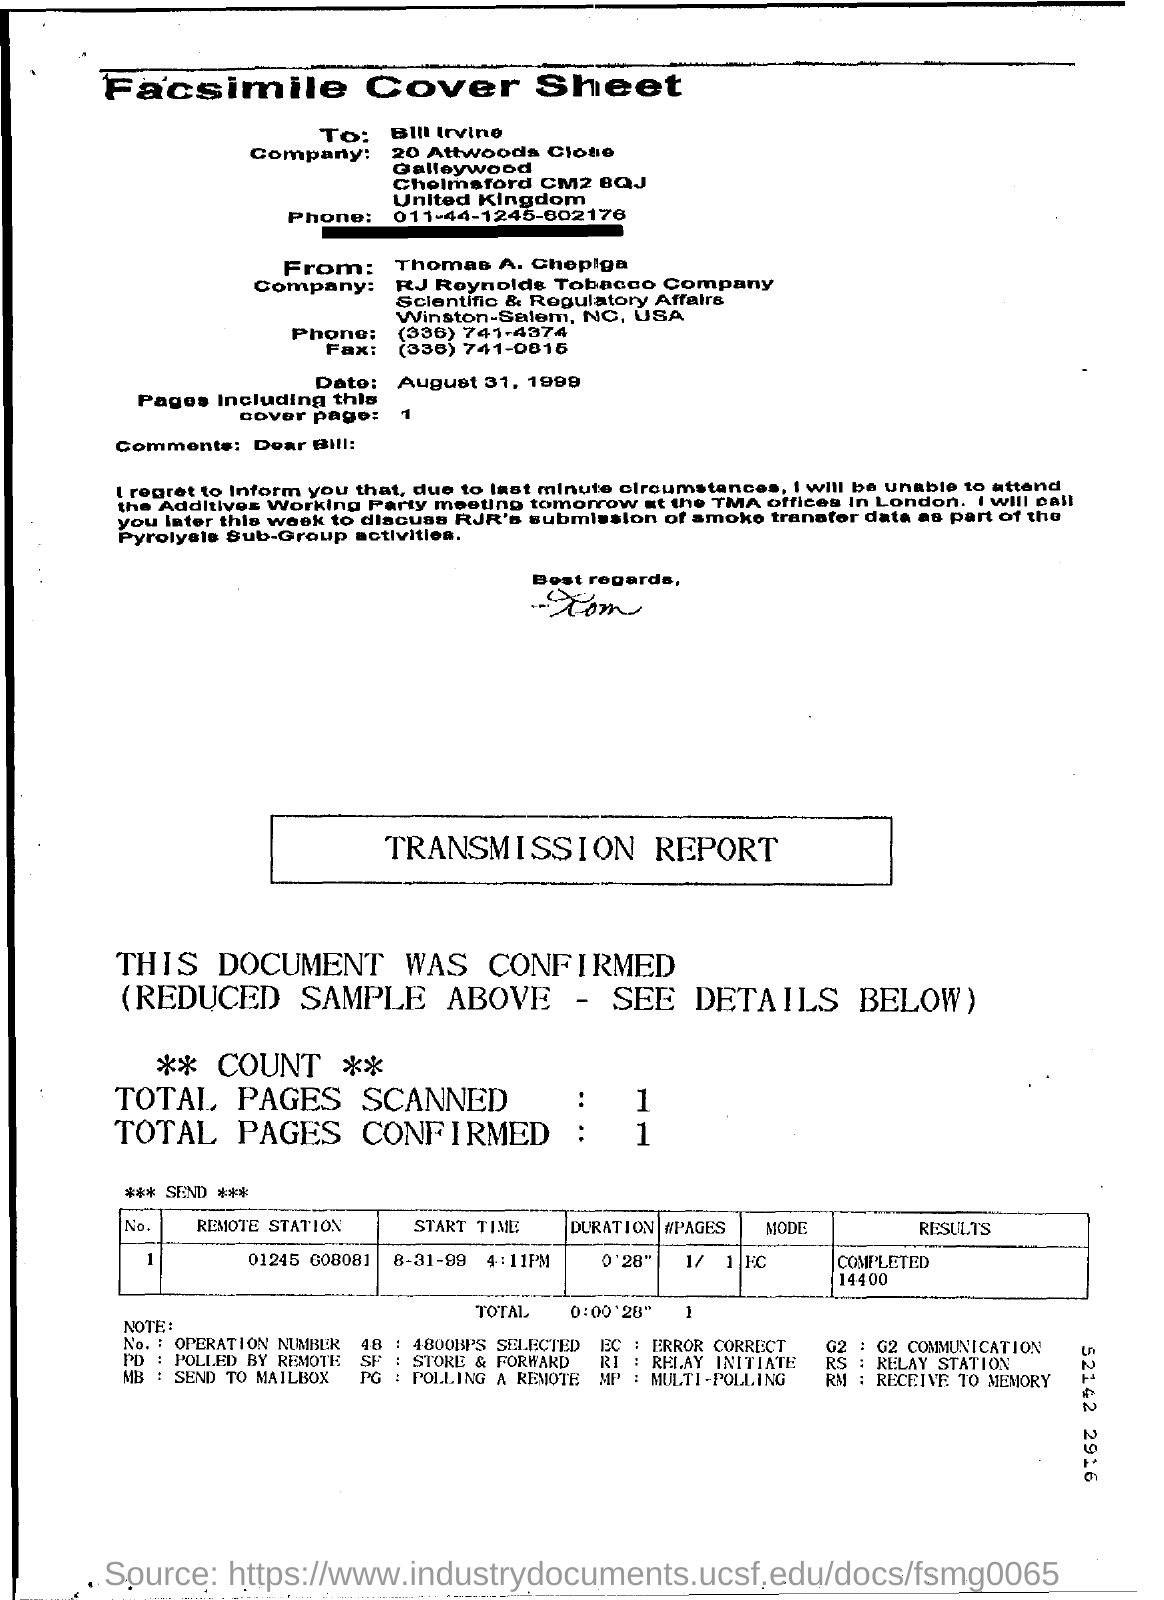Specify some key components in this picture. The fax is addressed to Bill Irvine. The start time for the Remote station with the number 01245 608081 is 4:11 PM. The result for the remote station number 01245 608081 has been completed and is 14400. The date is August 31, 1999. 